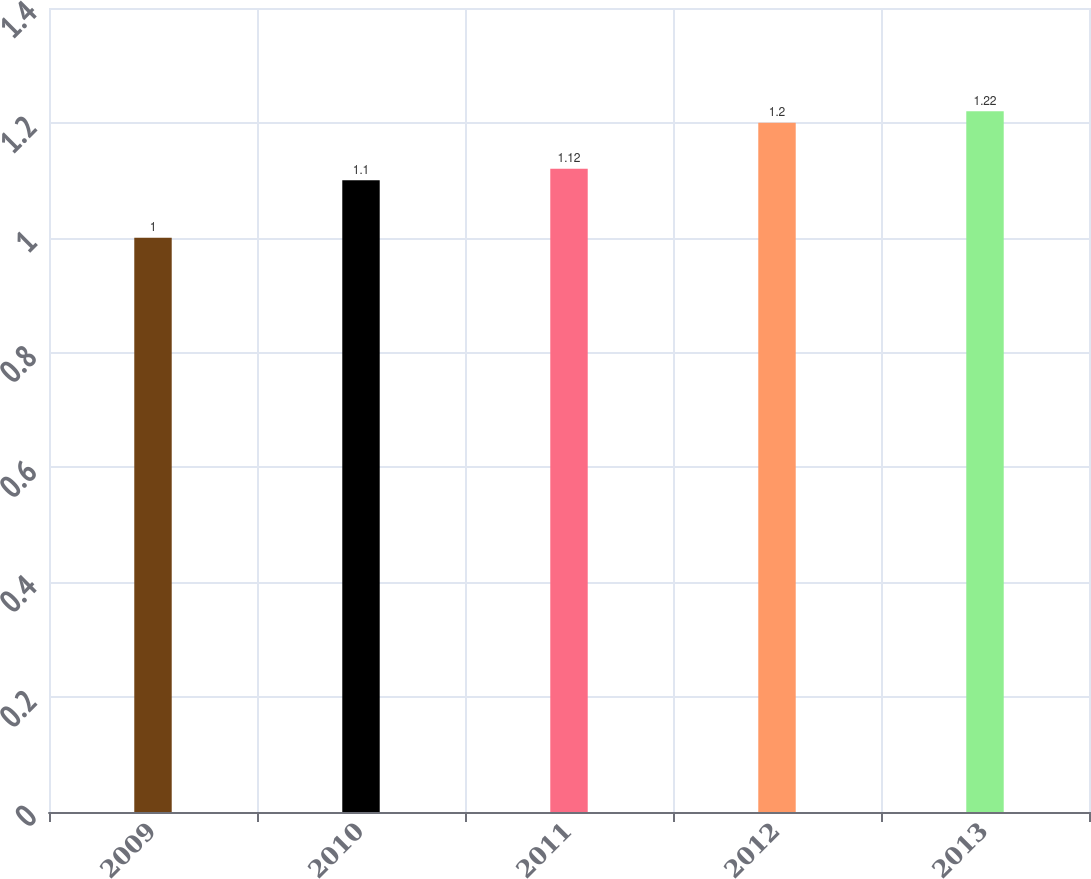<chart> <loc_0><loc_0><loc_500><loc_500><bar_chart><fcel>2009<fcel>2010<fcel>2011<fcel>2012<fcel>2013<nl><fcel>1<fcel>1.1<fcel>1.12<fcel>1.2<fcel>1.22<nl></chart> 